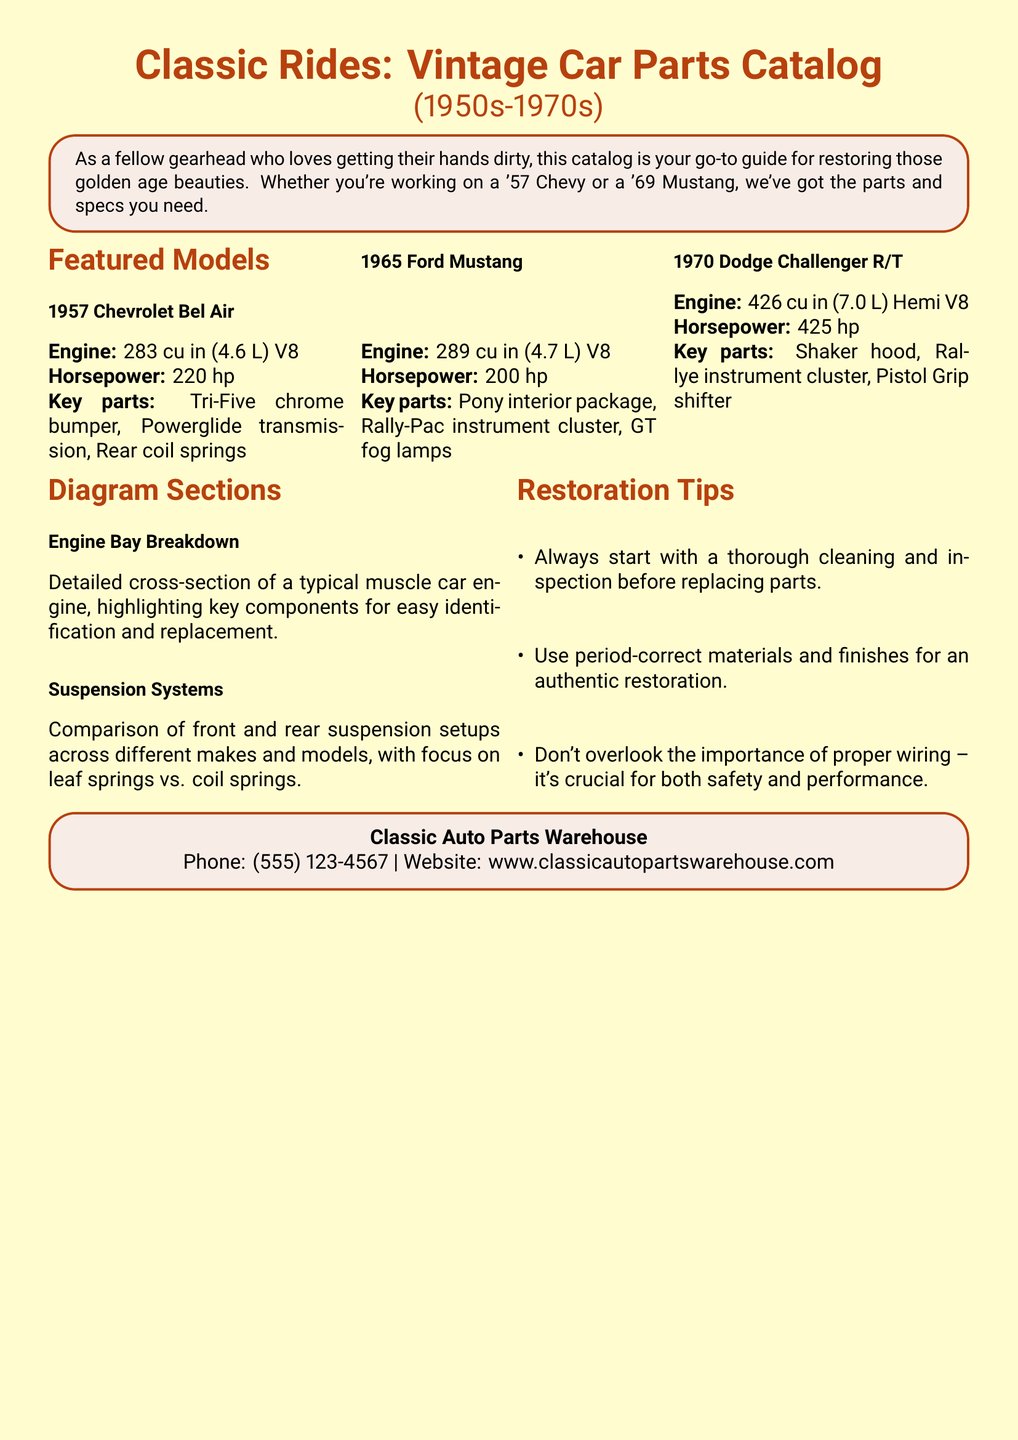What is the horsepower of the 1957 Chevrolet Bel Air? The horsepower of the 1957 Chevrolet Bel Air is listed in the document as 220 hp.
Answer: 220 hp What is the engine displacement of the 1965 Ford Mustang? The engine displacement for the 1965 Ford Mustang is mentioned as 289 cu in (4.7 L) V8.
Answer: 289 cu in (4.7 L) What key part is highlighted for the 1970 Dodge Challenger R/T? One of the key parts for the 1970 Dodge Challenger R/T mentioned is the Shaker hood.
Answer: Shaker hood What is a restoration tip provided in the document? The document offers several restoration tips; one is to start with a thorough cleaning and inspection before replacing parts.
Answer: Thorough cleaning and inspection How many featured models are listed in the document? The document mentions three featured models, including the 1957 Chevrolet Bel Air, 1965 Ford Mustang, and 1970 Dodge Challenger R/T.
Answer: Three What illustration section focuses on suspension systems? The document contains a section titled "Suspension Systems" that compares setups across different makes and models.
Answer: Suspension Systems What type of company is Classic Auto Parts Warehouse? Classic Auto Parts Warehouse is a company that sells auto parts for vintage vehicles, as indicated in the contact information section.
Answer: Auto parts warehouse What is the contact phone number for Classic Auto Parts Warehouse? The contact phone number listed for Classic Auto Parts Warehouse is (555) 123-4567.
Answer: (555) 123-4567 